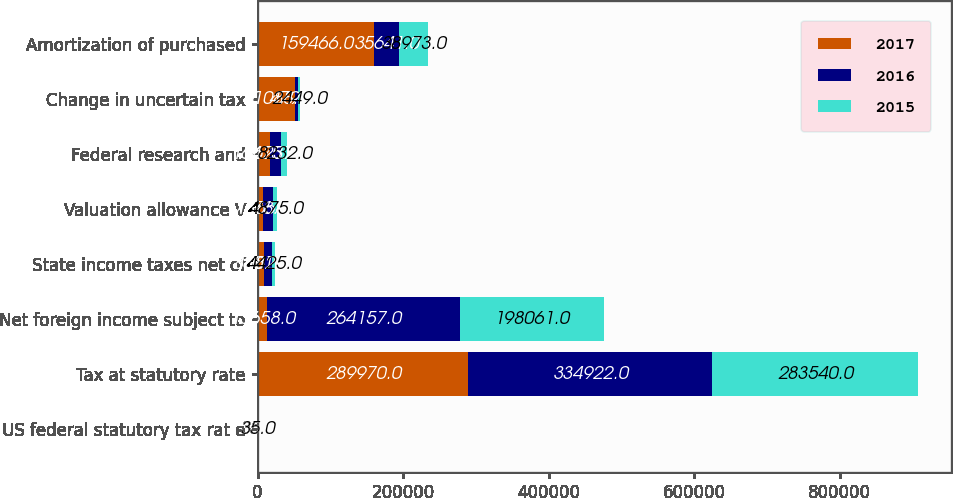Convert chart. <chart><loc_0><loc_0><loc_500><loc_500><stacked_bar_chart><ecel><fcel>US federal statutory tax rat e<fcel>Tax at statutory rate<fcel>Net foreign income subject to<fcel>State income taxes net of<fcel>Valuation allowance V<fcel>Federal research and<fcel>Change in uncertain tax<fcel>Amortization of purchased<nl><fcel>2017<fcel>35<fcel>289970<fcel>13658<fcel>8801<fcel>7778<fcel>16475<fcel>51088<fcel>159466<nl><fcel>2016<fcel>35<fcel>334922<fcel>264157<fcel>10821<fcel>13658<fcel>16237<fcel>4797<fcel>35641<nl><fcel>2015<fcel>35<fcel>283540<fcel>198061<fcel>4425<fcel>4875<fcel>8232<fcel>2449<fcel>38973<nl></chart> 